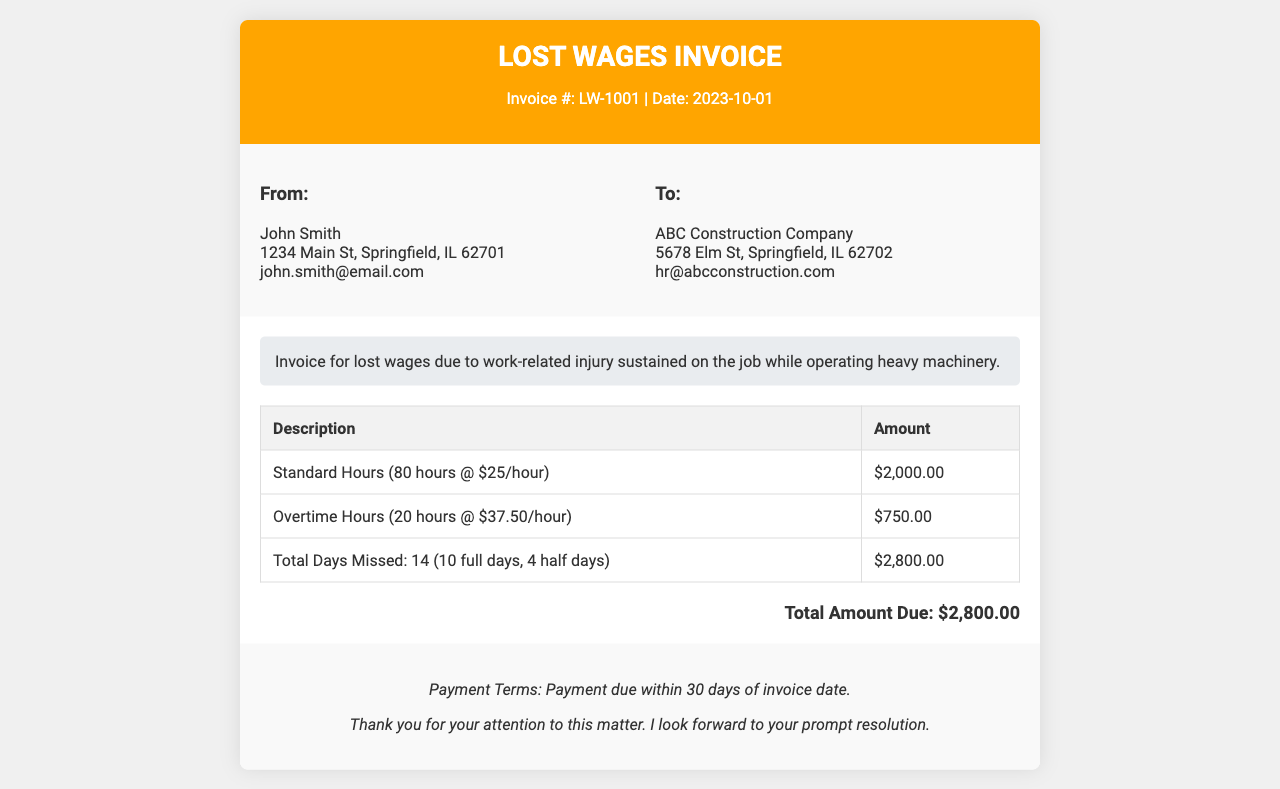what is the invoice number? The invoice number is provided at the top of the invoice in the header section.
Answer: LW-1001 what is the date of the invoice? The date is located next to the invoice number in the header section.
Answer: 2023-10-01 how many standard hours are billed? The number of standard hours is listed in the table detailing the amounts.
Answer: 80 hours what is the hourly rate for overtime? The overtime hourly rate is mentioned in the invoice body for overtime hours.
Answer: $37.50/hour what is the total amount due? The total amount due is presented at the bottom of the invoice body.
Answer: $2,800.00 how many full days were missed? The information regarding the number of full and half days missed is included in a table row.
Answer: 10 full days what is the total number of hours billed? The total hours billed is calculated by adding standard and overtime hours indicated in the invoice.
Answer: 100 hours what are the payment terms? The payment terms are stated in the footer section of the invoice.
Answer: Payment due within 30 days of invoice date who is the recipient of this invoice? The recipient's information is provided in the "To" section of the invoice details.
Answer: ABC Construction Company 